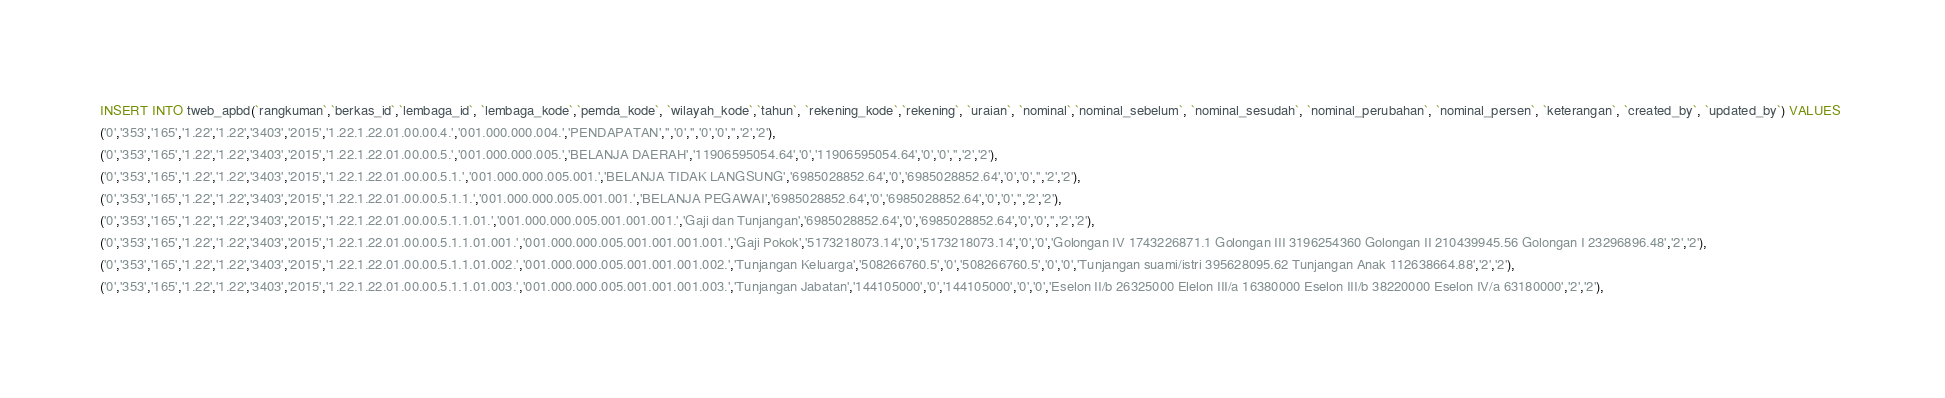<code> <loc_0><loc_0><loc_500><loc_500><_SQL_>INSERT INTO tweb_apbd(`rangkuman`,`berkas_id`,`lembaga_id`, `lembaga_kode`,`pemda_kode`, `wilayah_kode`,`tahun`, `rekening_kode`,`rekening`, `uraian`, `nominal`,`nominal_sebelum`, `nominal_sesudah`, `nominal_perubahan`, `nominal_persen`, `keterangan`, `created_by`, `updated_by`) VALUES 
('0','353','165','1.22','1.22','3403','2015','1.22.1.22.01.00.00.4.','001.000.000.004.','PENDAPATAN','','0','','0','0','','2','2'),
('0','353','165','1.22','1.22','3403','2015','1.22.1.22.01.00.00.5.','001.000.000.005.','BELANJA DAERAH','11906595054.64','0','11906595054.64','0','0','','2','2'),
('0','353','165','1.22','1.22','3403','2015','1.22.1.22.01.00.00.5.1.','001.000.000.005.001.','BELANJA TIDAK LANGSUNG','6985028852.64','0','6985028852.64','0','0','','2','2'),
('0','353','165','1.22','1.22','3403','2015','1.22.1.22.01.00.00.5.1.1.','001.000.000.005.001.001.','BELANJA PEGAWAI','6985028852.64','0','6985028852.64','0','0','','2','2'),
('0','353','165','1.22','1.22','3403','2015','1.22.1.22.01.00.00.5.1.1.01.','001.000.000.005.001.001.001.','Gaji dan Tunjangan','6985028852.64','0','6985028852.64','0','0','','2','2'),
('0','353','165','1.22','1.22','3403','2015','1.22.1.22.01.00.00.5.1.1.01.001.','001.000.000.005.001.001.001.001.','Gaji Pokok','5173218073.14','0','5173218073.14','0','0','Golongan IV 1743226871.1 Golongan III 3196254360 Golongan II 210439945.56 Golongan I 23296896.48','2','2'),
('0','353','165','1.22','1.22','3403','2015','1.22.1.22.01.00.00.5.1.1.01.002.','001.000.000.005.001.001.001.002.','Tunjangan Keluarga','508266760.5','0','508266760.5','0','0','Tunjangan suami/istri 395628095.62 Tunjangan Anak 112638664.88','2','2'),
('0','353','165','1.22','1.22','3403','2015','1.22.1.22.01.00.00.5.1.1.01.003.','001.000.000.005.001.001.001.003.','Tunjangan Jabatan','144105000','0','144105000','0','0','Eselon II/b 26325000 Elelon III/a 16380000 Eselon III/b 38220000 Eselon IV/a 63180000','2','2'),</code> 